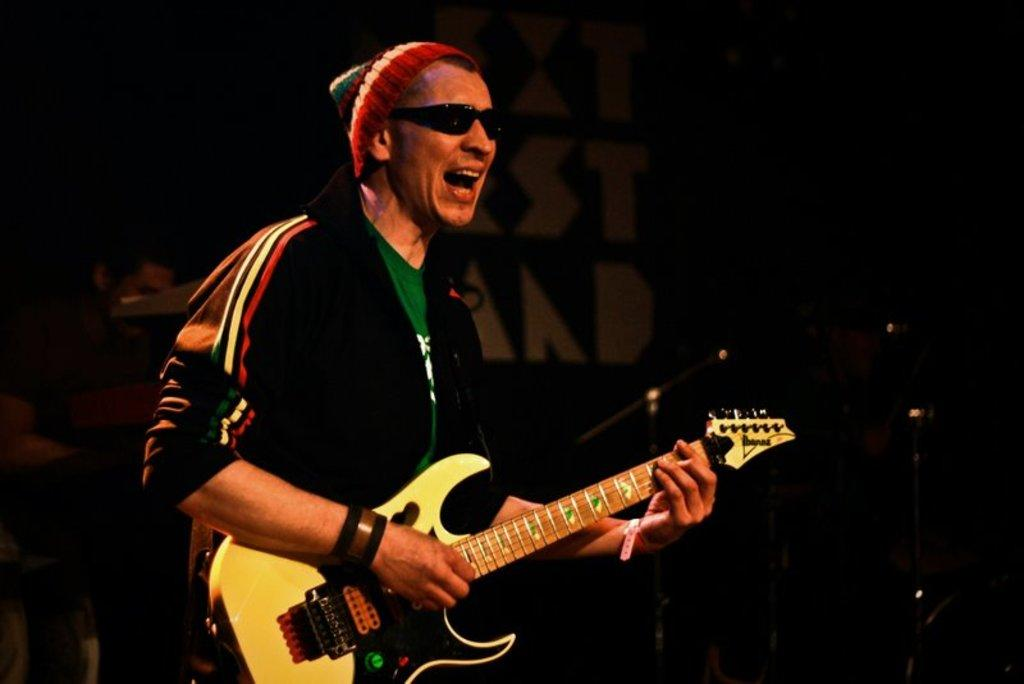What is the man in the image doing? The man is playing a guitar and singing. What accessories is the man wearing while playing the guitar? The man is wearing goggles and a cap. What type of wind instrument is the man playing in the image? The man is not playing a wind instrument in the image; he is playing a guitar, which is a stringed instrument. 